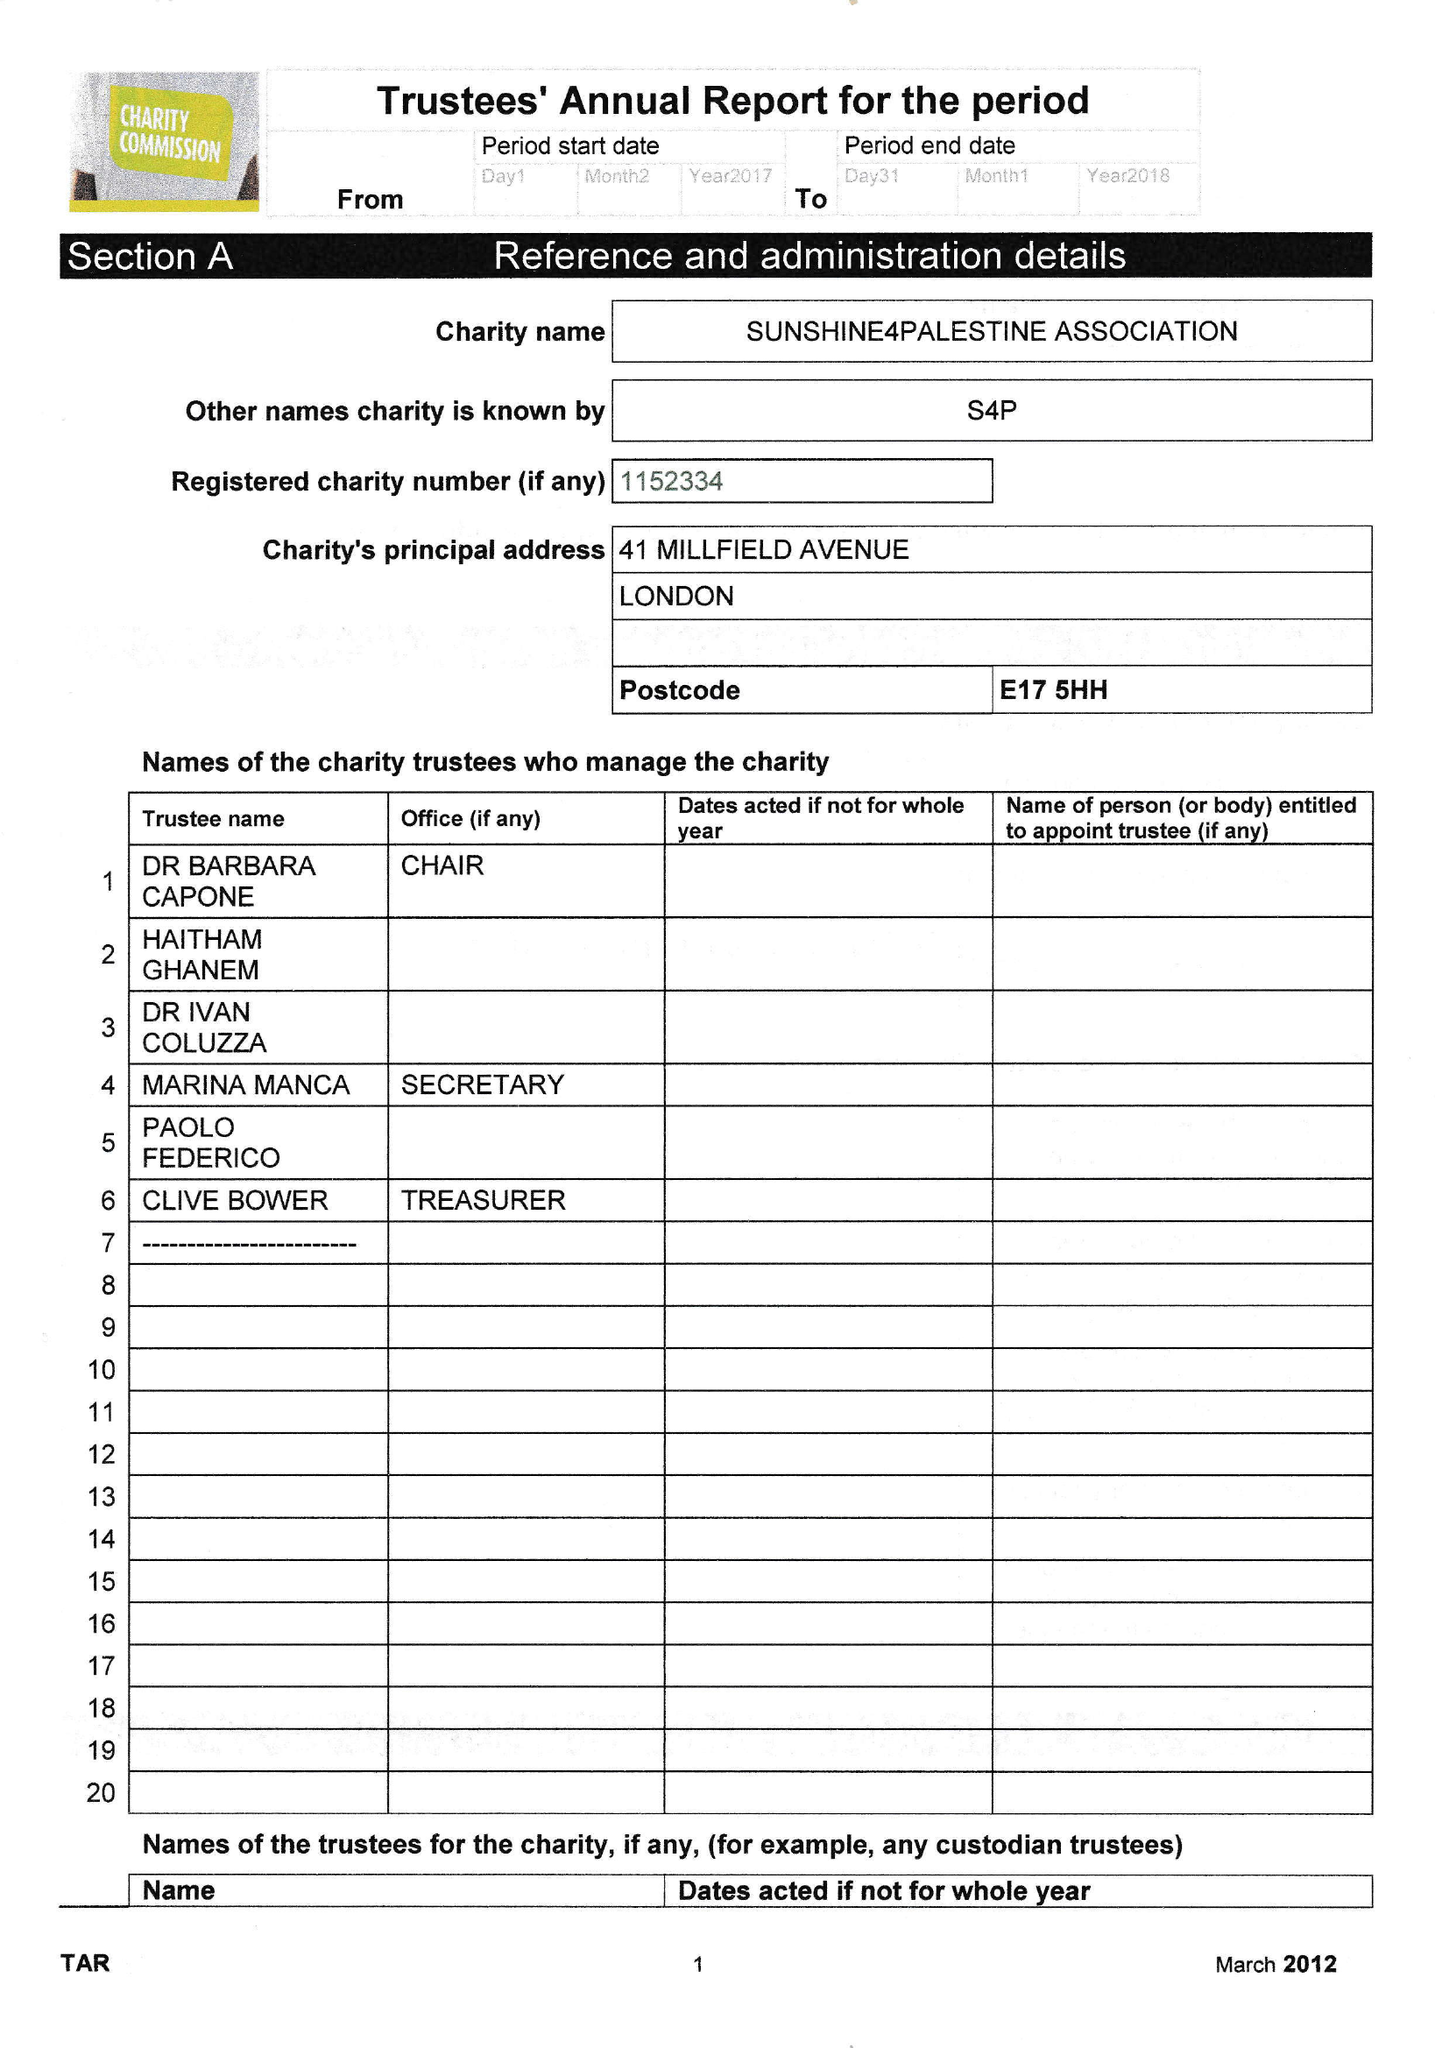What is the value for the address__street_line?
Answer the question using a single word or phrase. 41 MILLFIELD AVENUE 